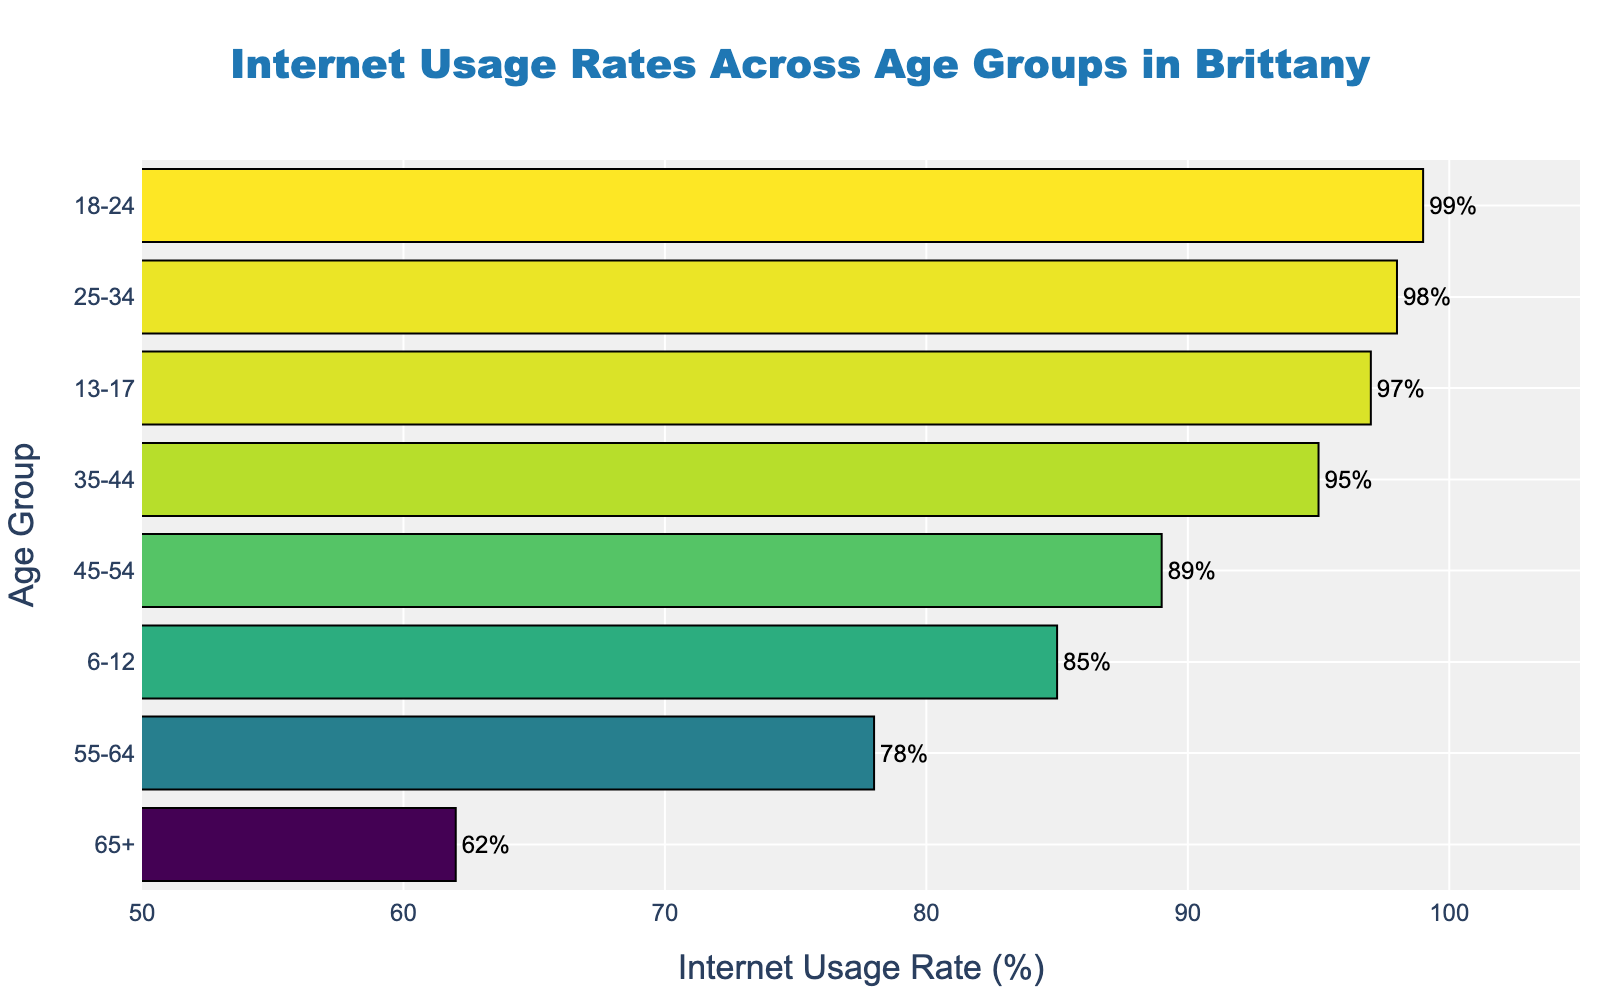what is the main title of the plot? The main title of the plot is clearly displayed at the top. It reads 'Internet Usage Rates Across Age Groups in Brittany'.
Answer: Internet Usage Rates Across Age Groups in Brittany Which age group has the highest internet usage rate? By looking at the lengths of the bars, the longest bar represents the 18-24 age group, which has a 99% usage rate, making it the highest.
Answer: 18-24 what is the internet usage rate for the age group 55-64? Locate the bar corresponding to the 55-64 age group, then check the value displayed at the end of the bar, which reads '78%'.
Answer: 78% How many age groups have an internet usage rate above 90%? Observe the figure and count the number of bars where the percentage value is greater than 90%. These are the age groups 45-54, 35-44, 25-34, and 18-24.
Answer: 4 what is the difference in internet usage rate between the 13-17 and 6-12 age groups? Find the bars for the 13-17 and 6-12 age groups, which have rates of 97% and 85%, respectively. Subtract the smaller rate from the larger: 97% - 85% = 12%.
Answer: 12% Which age group has a lower internet usage rate: 65+ or 6-12? Locate the bars for both age groups. The 65+ age group has a rate of 62%, while the 6-12 age group has a rate of 85%. 62% is lower than 85%.
Answer: 65+ what is the average internet usage rate for all age groups listed? Add up all the rates (62% + 78% + 89% + 95% + 98% + 99% + 97% + 85%) and then divide by the number of age groups, which is 8. The sum is 703%. The average is 703%/8 = 87.875%.
Answer: 87.875% What color is used for the bar representing the age group 25-34? Each bar is colored based on the 'Viridis' colorscale. The color becomes evident when viewing the 25-34 bar, which has a greenish hue.
Answer: Greenish what percentage of internet usage does the age group 13-17 have compared to 45-54? The 13-17 age group has a usage rate of 97%, and the 45-54 age group has a rate of 89%. Comparing these, 97% is higher than 89%.
Answer: 97% Is the internet usage rate of the 65+ age group less than 2/3 of the 18-24 age group? Calculate 2/3 of the 18-24 age group's rate, which is 99% * (2/3) = 66%. The 65+ age group has a rate of 62%, which is less than 66%.
Answer: Yes 